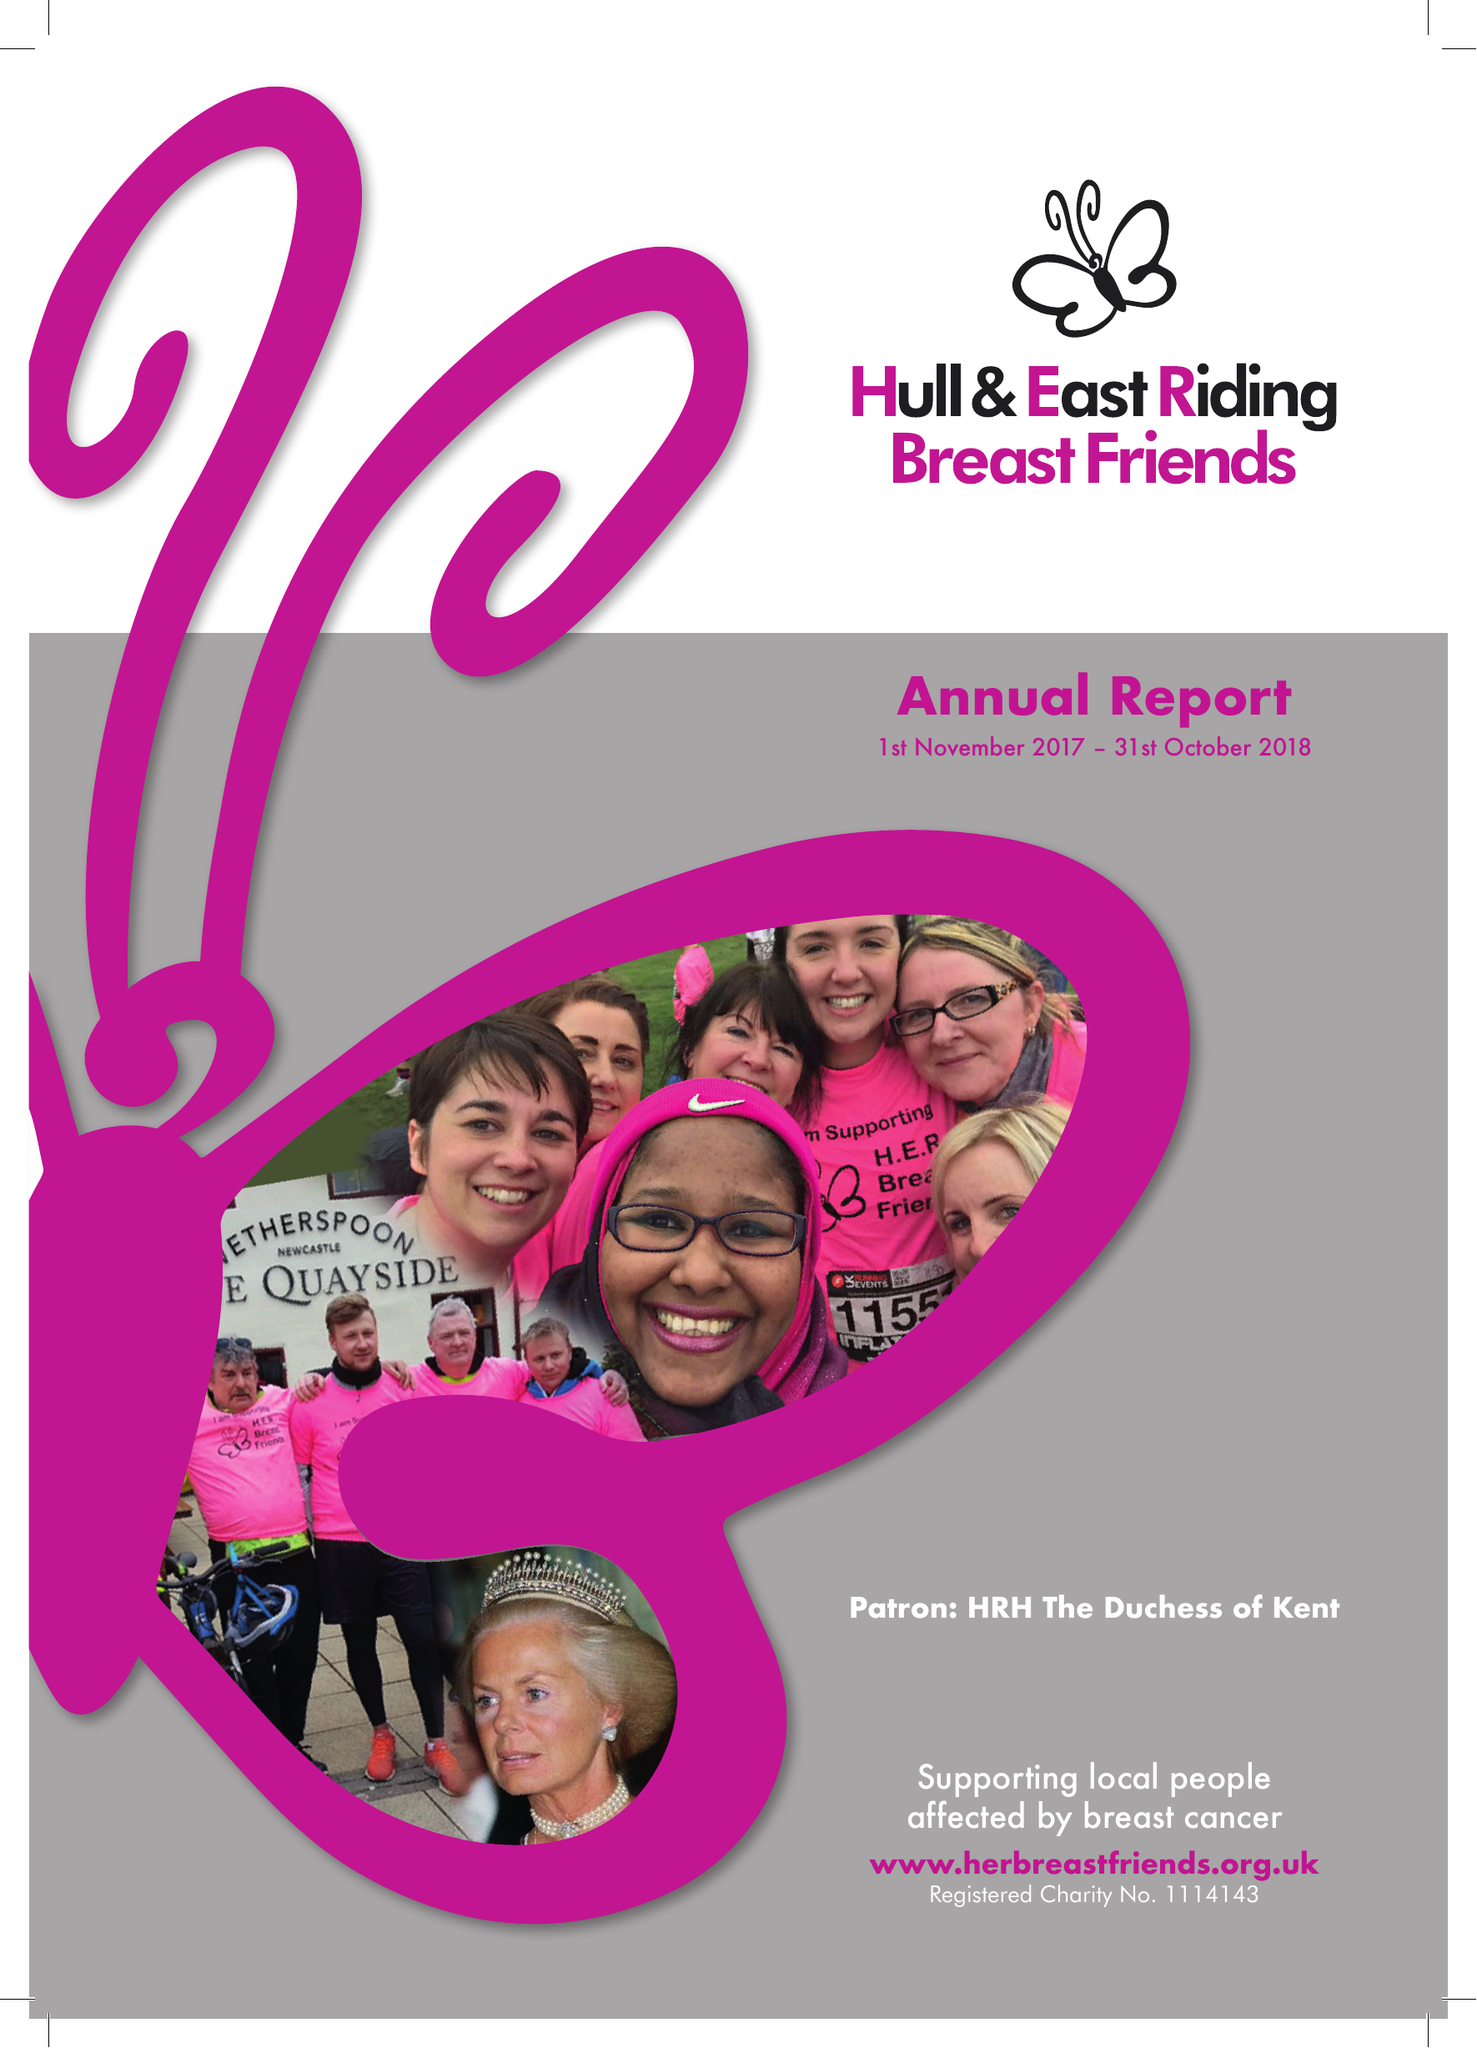What is the value for the charity_number?
Answer the question using a single word or phrase. 1114143 